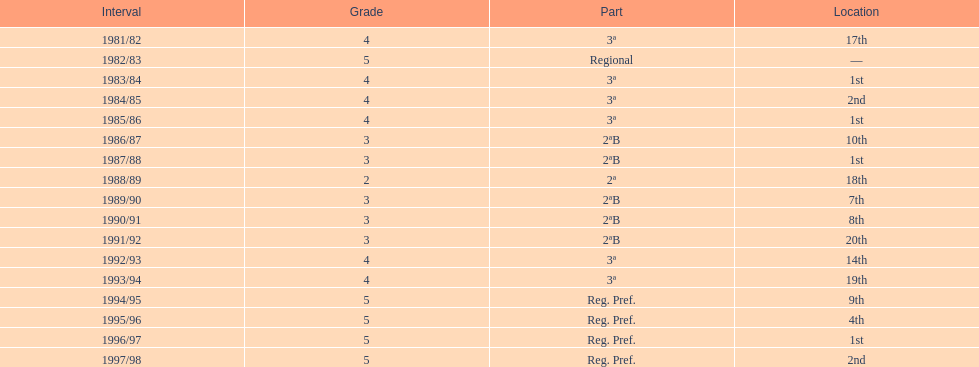How many times was the runner-up position achieved? 2. 